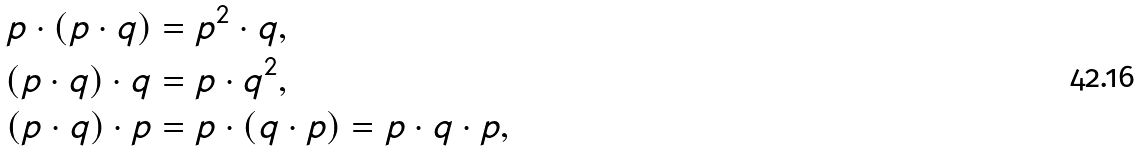<formula> <loc_0><loc_0><loc_500><loc_500>p \cdot ( p \cdot q ) & = p ^ { 2 } \cdot q , \\ ( p \cdot q ) \cdot q & = p \cdot q ^ { 2 } , \\ ( p \cdot q ) \cdot p & = p \cdot ( q \cdot p ) = p \cdot q \cdot p ,</formula> 